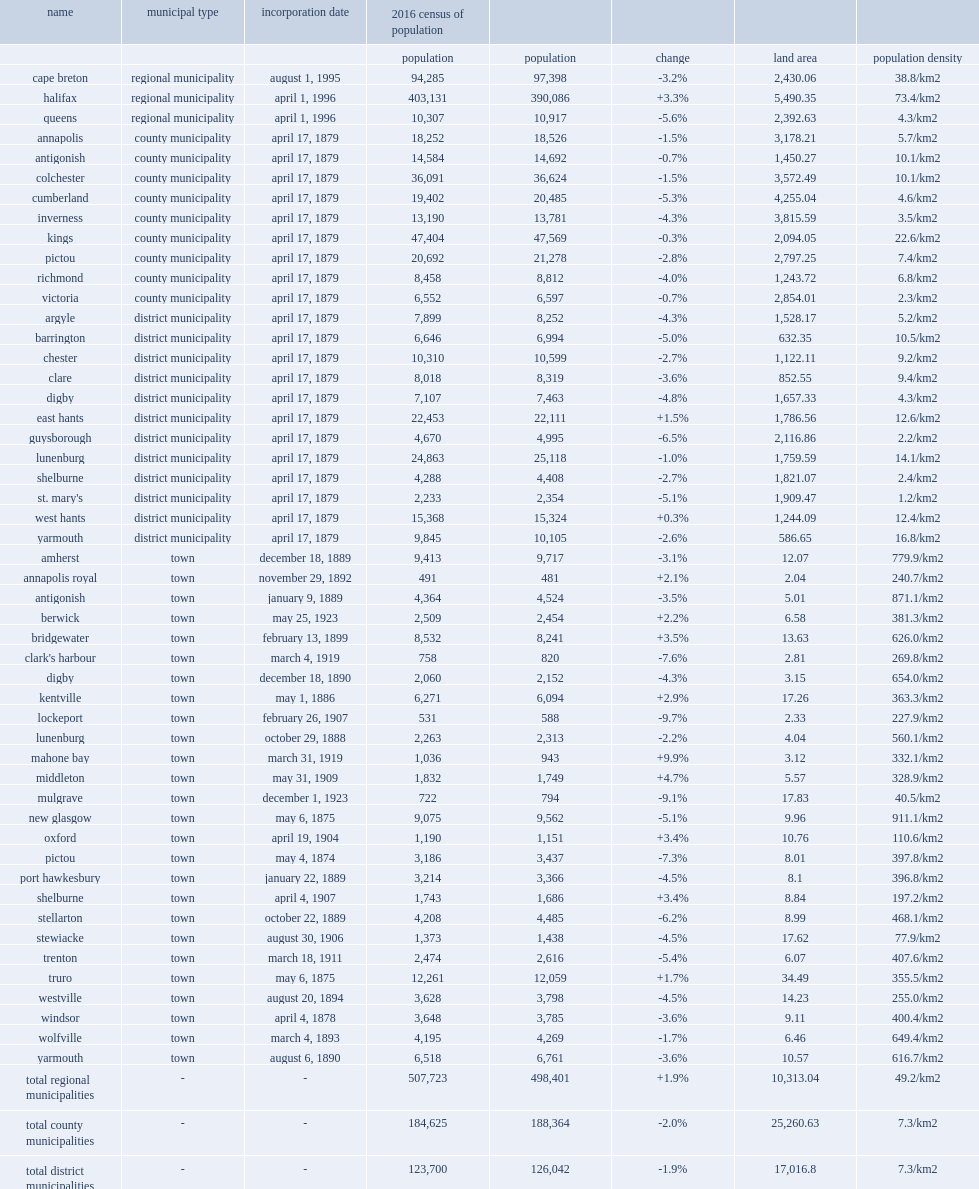What was the land area of truro town(km2)? 34.49. 